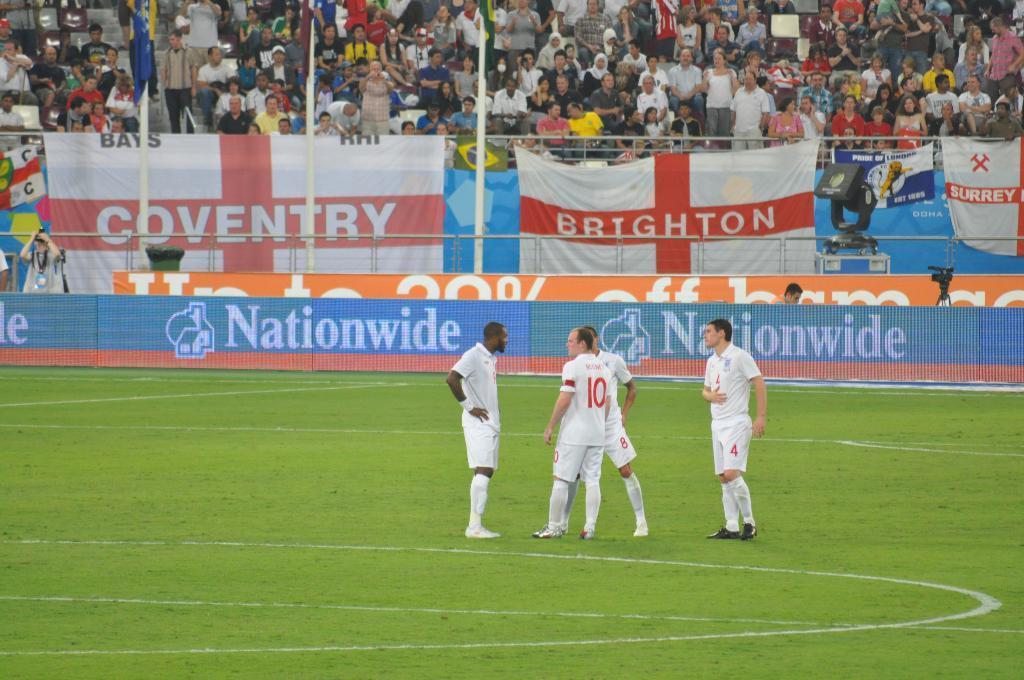Please provide a concise description of this image. In this image there are persons standing in the stadium. In the background there are boards with some text written on it and there are persons standing and sitting and there are banners with some text on it and there is a camera and there is an object which is black in colour. On the ground there is grass. 